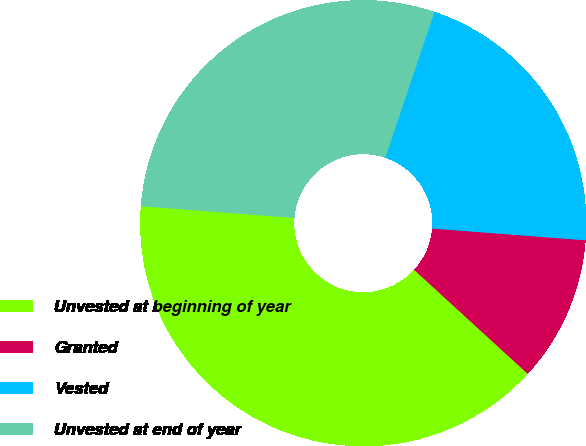Convert chart. <chart><loc_0><loc_0><loc_500><loc_500><pie_chart><fcel>Unvested at beginning of year<fcel>Granted<fcel>Vested<fcel>Unvested at end of year<nl><fcel>39.42%<fcel>10.58%<fcel>21.05%<fcel>28.95%<nl></chart> 